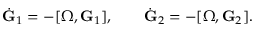<formula> <loc_0><loc_0><loc_500><loc_500>\begin{array} { r } { \dot { G } _ { 1 } = - [ { \boldsymbol \Omega } , { G } _ { 1 } ] , \quad \dot { G } _ { 2 } = - [ { \boldsymbol \Omega } , { G } _ { 2 } ] . } \end{array}</formula> 